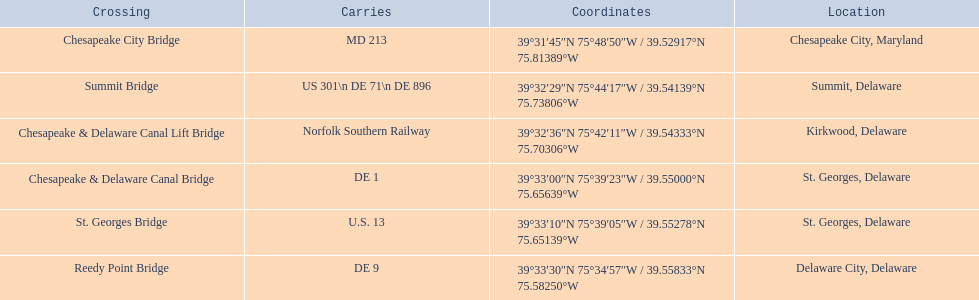Which crossing carries the most routes (e.g., de 1)? Summit Bridge. 